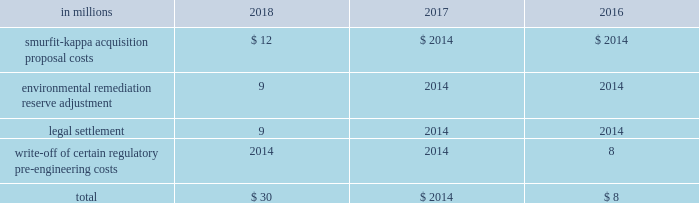Other corporate special items in addition , other pre-tax corporate special items totaling $ 30 million , $ 0 million and $ 8 million were recorded in 2018 , 2017 and 2016 , respectively .
Details of these charges were as follows : other corporate items .
Impairments of goodwill no goodwill impairment charges were recorded in 2018 , 2017 or 2016 .
Net losses on sales and impairments of businesses net losses on sales and impairments of businesses included in special items totaled a pre-tax loss of $ 122 million in 2018 related to the impairment of an intangible asset and fixed assets in the brazil packaging business , a pre-tax loss of $ 9 million in 2017 related to the write down of the long-lived assets of the company's asia foodservice business to fair value and a pre-tax loss of $ 70 million related to severance and the impairment of the ip asia packaging business in 2016 .
See note 8 divestitures and impairments on pages 54 and 55 of item 8 .
Financial statements and supplementary data for further discussion .
Description of business segments international paper 2019s business segments discussed below are consistent with the internal structure used to manage these businesses .
All segments are differentiated on a common product , common customer basis consistent with the business segmentation generally used in the forest products industry .
Industrial packaging international paper is the largest manufacturer of containerboard in the united states .
Our u.s .
Production capacity is over 13 million tons annually .
Our products include linerboard , medium , whitetop , recycled linerboard , recycled medium and saturating kraft .
About 80% ( 80 % ) of our production is converted into corrugated boxes and other packaging by our 179 north american container plants .
Additionally , we recycle approximately one million tons of occ and mixed and white paper through our 18 recycling plants .
Our container plants are supported by regional design centers , which offer total packaging solutions and supply chain initiatives .
In emea , our operations include one recycled fiber containerboard mill in morocco , a recycled containerboard mill in spain and 26 container plants in france , italy , spain , morocco and turkey .
In brazil , our operations include three containerboard mills and four box plants .
International paper also produces high quality coated paperboard for a variety of packaging end uses with 428000 tons of annual capacity at our mills in poland and russia .
Global cellulose fibers our cellulose fibers product portfolio includes fluff , market and specialty pulps .
International paper is the largest producer of fluff pulp which is used to make absorbent hygiene products like baby diapers , feminine care , adult incontinence and other non-woven products .
Our market pulp is used for tissue and paper products .
We continue to invest in exploring new innovative uses for our products , such as our specialty pulps , which are used for non-absorbent end uses including textiles , filtration , construction material , paints and coatings , reinforced plastics and more .
Our products are made in the united states , canada , france , poland , and russia and are sold around the world .
International paper facilities have annual dried pulp capacity of about 4 million metric tons .
Printing papers international paper is one of the world 2019s largest producers of printing and writing papers .
The primary product in this segment is uncoated papers .
This business produces papers for use in copiers , desktop and laser printers and digital imaging .
End-use applications include advertising and promotional materials such as brochures , pamphlets , greeting cards , books , annual reports and direct mail .
Uncoated papers also produces a variety of grades that are converted by our customers into envelopes , tablets , business forms and file folders .
Uncoated papers are sold under private label and international paper brand names that include hammermill , springhill , williamsburg , postmark , accent , great white , chamex , ballet , rey , pol , and svetocopy .
The mills producing uncoated papers are located in the united states , france , poland , russia , brazil and india .
The mills have uncoated paper production capacity of over 4 million tons annually .
Brazilian operations function through international paper do brasil , ltda , which owns or manages approximately 329000 acres of forestlands in brazil. .
Considering the other corporate special items in addition , what is the variation observed in the other pre-tax corporate special items during 2017 and 2018 , in millions of dollars? 
Rationale: it is the difference between those values .
Computations: (30 - 0)
Answer: 30.0. 